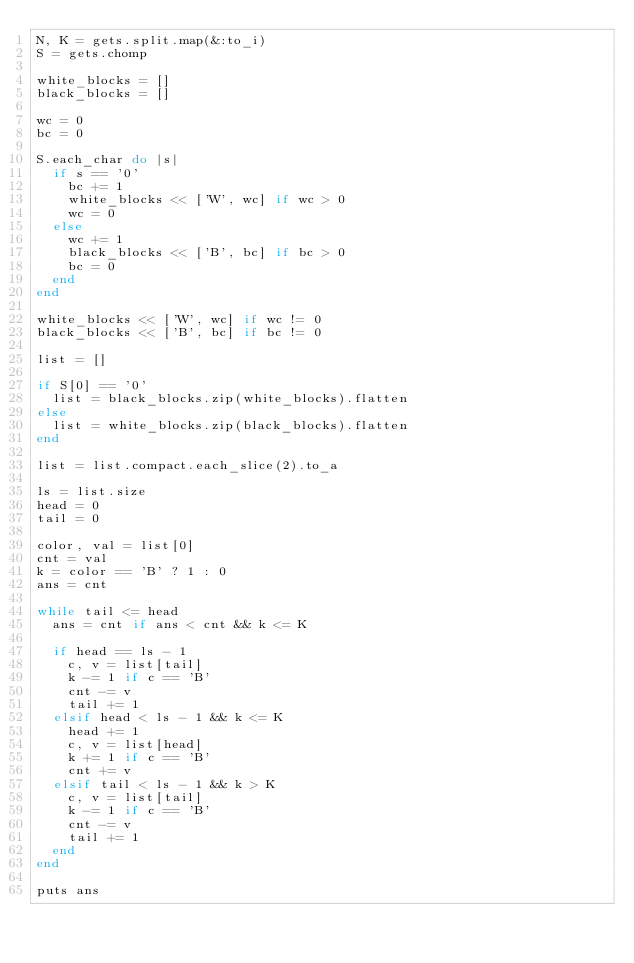Convert code to text. <code><loc_0><loc_0><loc_500><loc_500><_Ruby_>N, K = gets.split.map(&:to_i)
S = gets.chomp

white_blocks = []
black_blocks = []

wc = 0
bc = 0

S.each_char do |s|
  if s == '0'
    bc += 1
    white_blocks << ['W', wc] if wc > 0
    wc = 0
  else
    wc += 1
    black_blocks << ['B', bc] if bc > 0
    bc = 0
  end
end

white_blocks << ['W', wc] if wc != 0
black_blocks << ['B', bc] if bc != 0

list = []

if S[0] == '0'
  list = black_blocks.zip(white_blocks).flatten
else
  list = white_blocks.zip(black_blocks).flatten
end

list = list.compact.each_slice(2).to_a

ls = list.size
head = 0
tail = 0

color, val = list[0]
cnt = val
k = color == 'B' ? 1 : 0
ans = cnt

while tail <= head
  ans = cnt if ans < cnt && k <= K

  if head == ls - 1
    c, v = list[tail]
    k -= 1 if c == 'B'
    cnt -= v
    tail += 1
  elsif head < ls - 1 && k <= K
    head += 1
    c, v = list[head]
    k += 1 if c == 'B'
    cnt += v
  elsif tail < ls - 1 && k > K
    c, v = list[tail]
    k -= 1 if c == 'B'
    cnt -= v
    tail += 1
  end
end

puts ans
</code> 